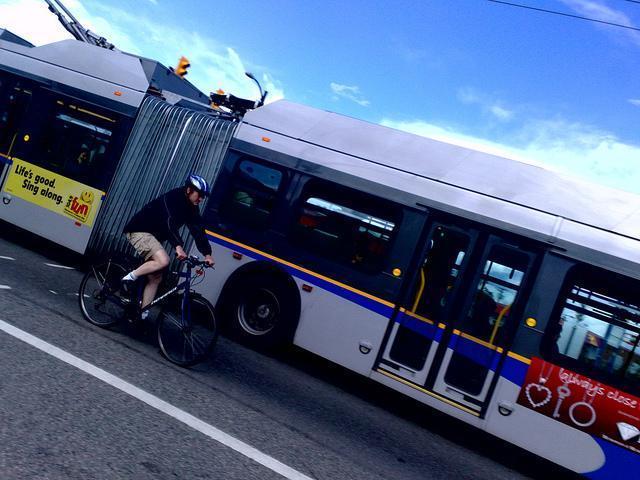How many people are in the picture?
Give a very brief answer. 1. How many birds are there?
Give a very brief answer. 0. 